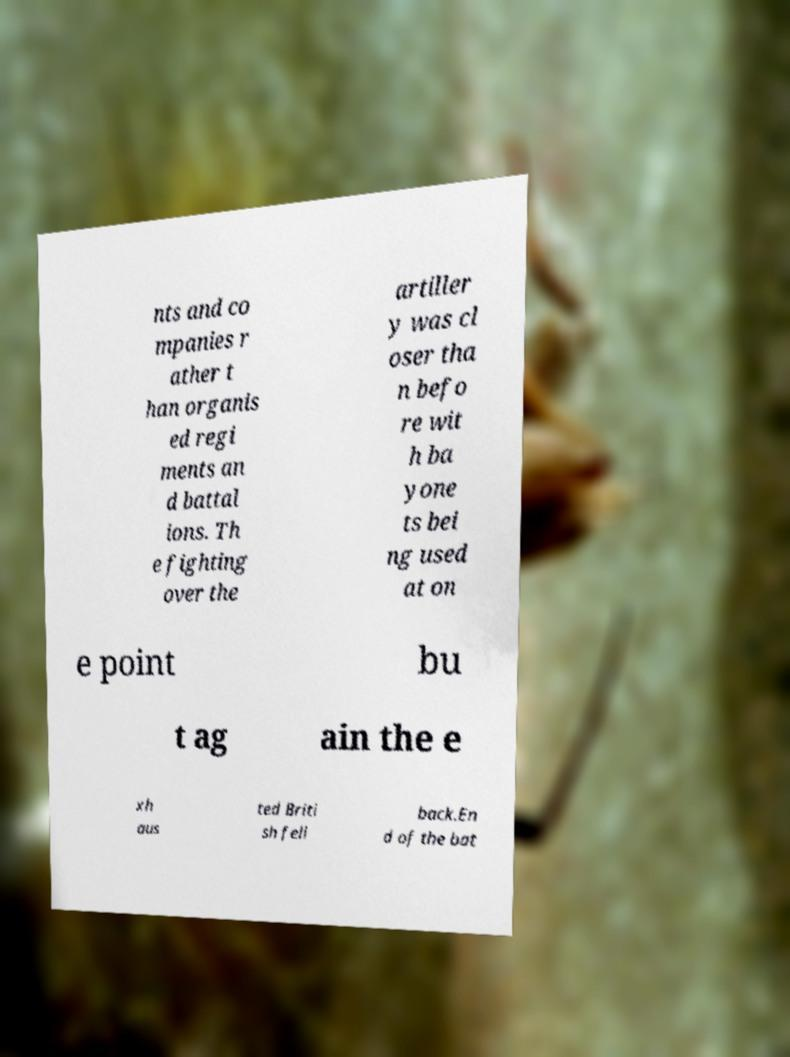Can you accurately transcribe the text from the provided image for me? nts and co mpanies r ather t han organis ed regi ments an d battal ions. Th e fighting over the artiller y was cl oser tha n befo re wit h ba yone ts bei ng used at on e point bu t ag ain the e xh aus ted Briti sh fell back.En d of the bat 